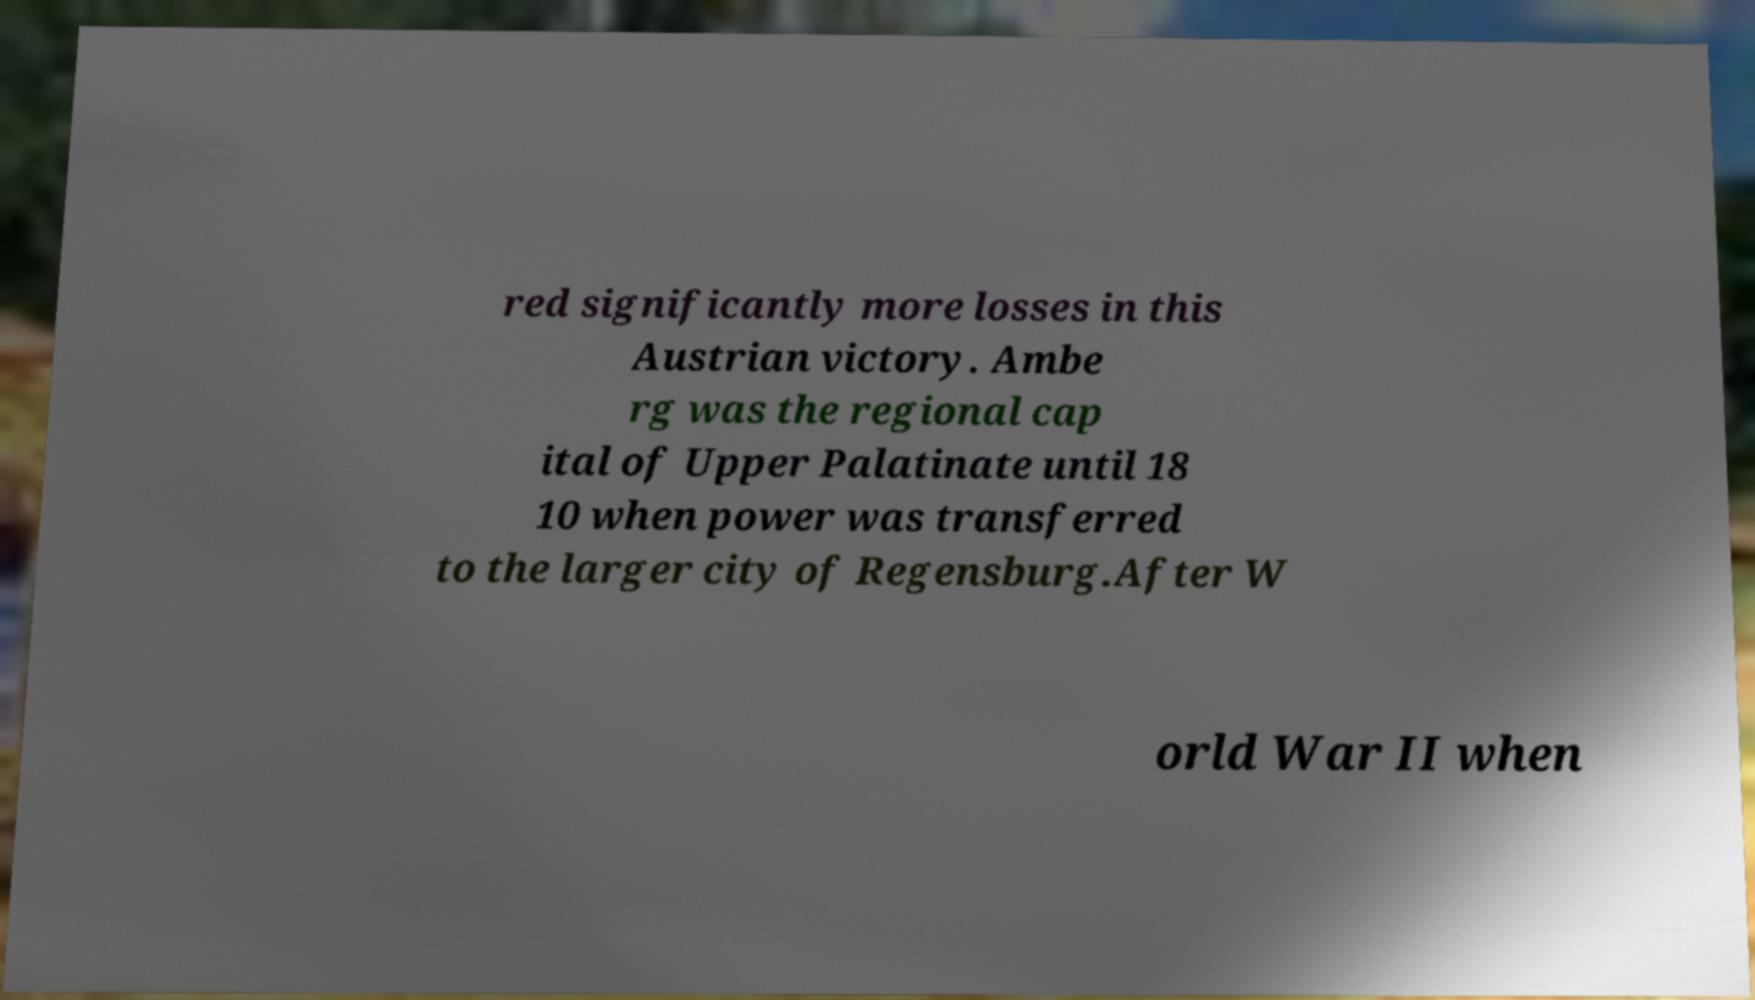There's text embedded in this image that I need extracted. Can you transcribe it verbatim? red significantly more losses in this Austrian victory. Ambe rg was the regional cap ital of Upper Palatinate until 18 10 when power was transferred to the larger city of Regensburg.After W orld War II when 